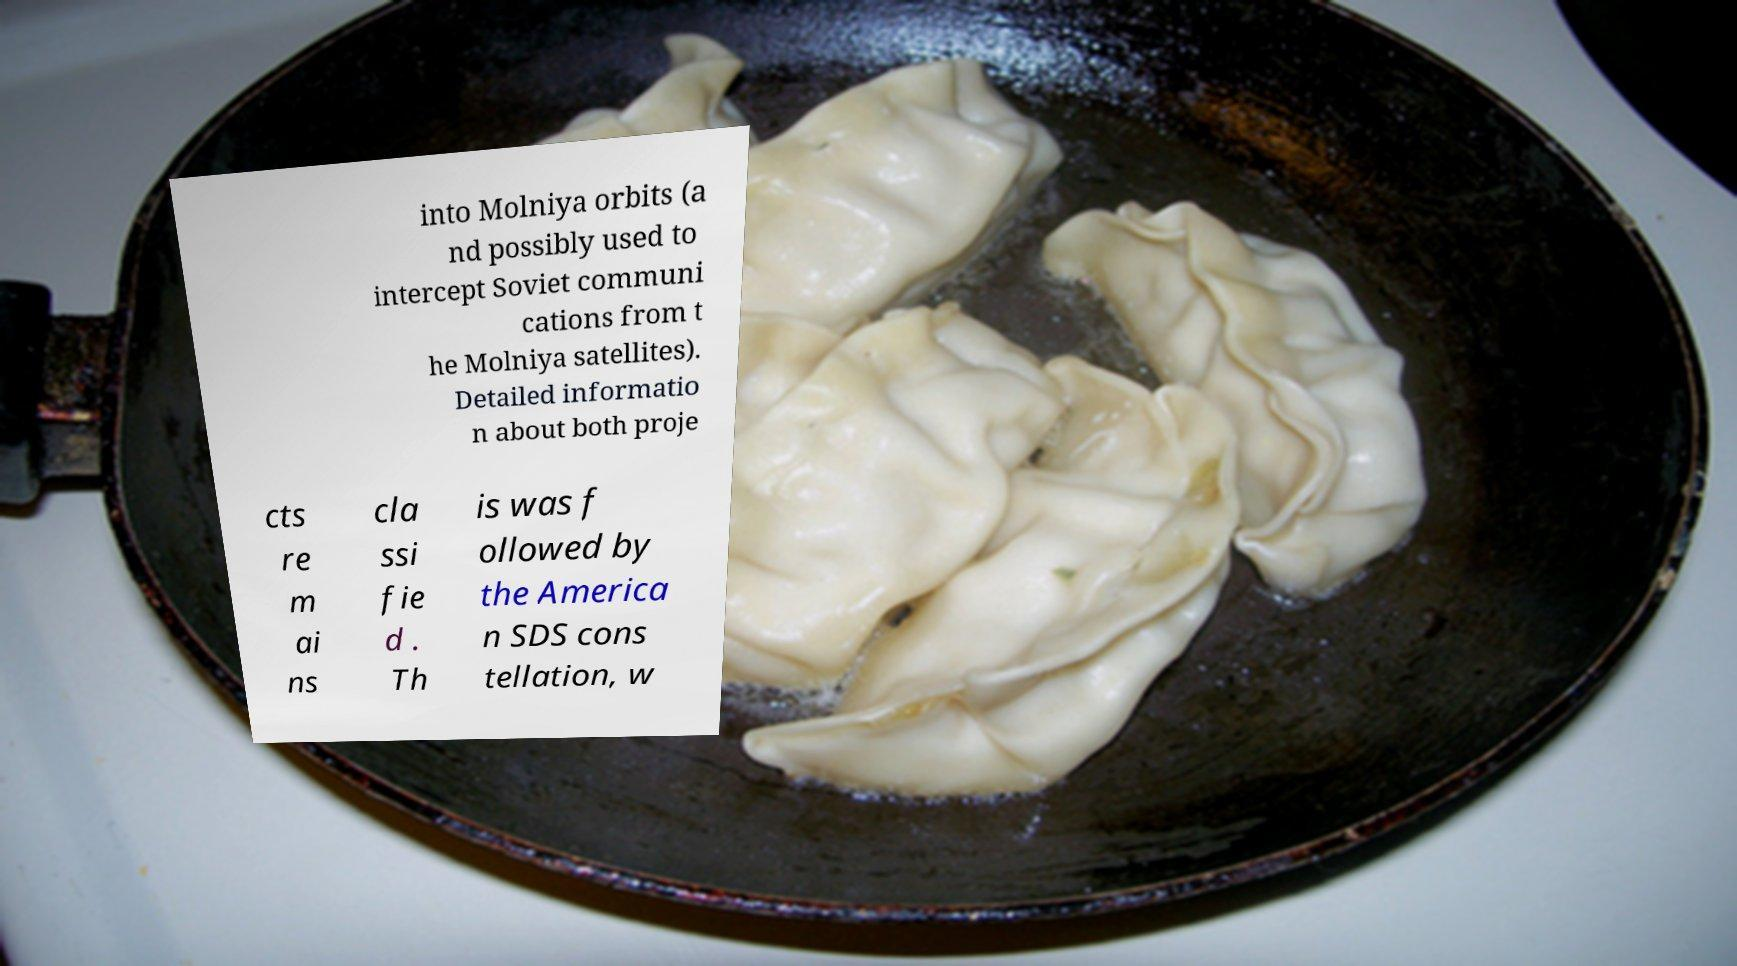Can you accurately transcribe the text from the provided image for me? into Molniya orbits (a nd possibly used to intercept Soviet communi cations from t he Molniya satellites). Detailed informatio n about both proje cts re m ai ns cla ssi fie d . Th is was f ollowed by the America n SDS cons tellation, w 